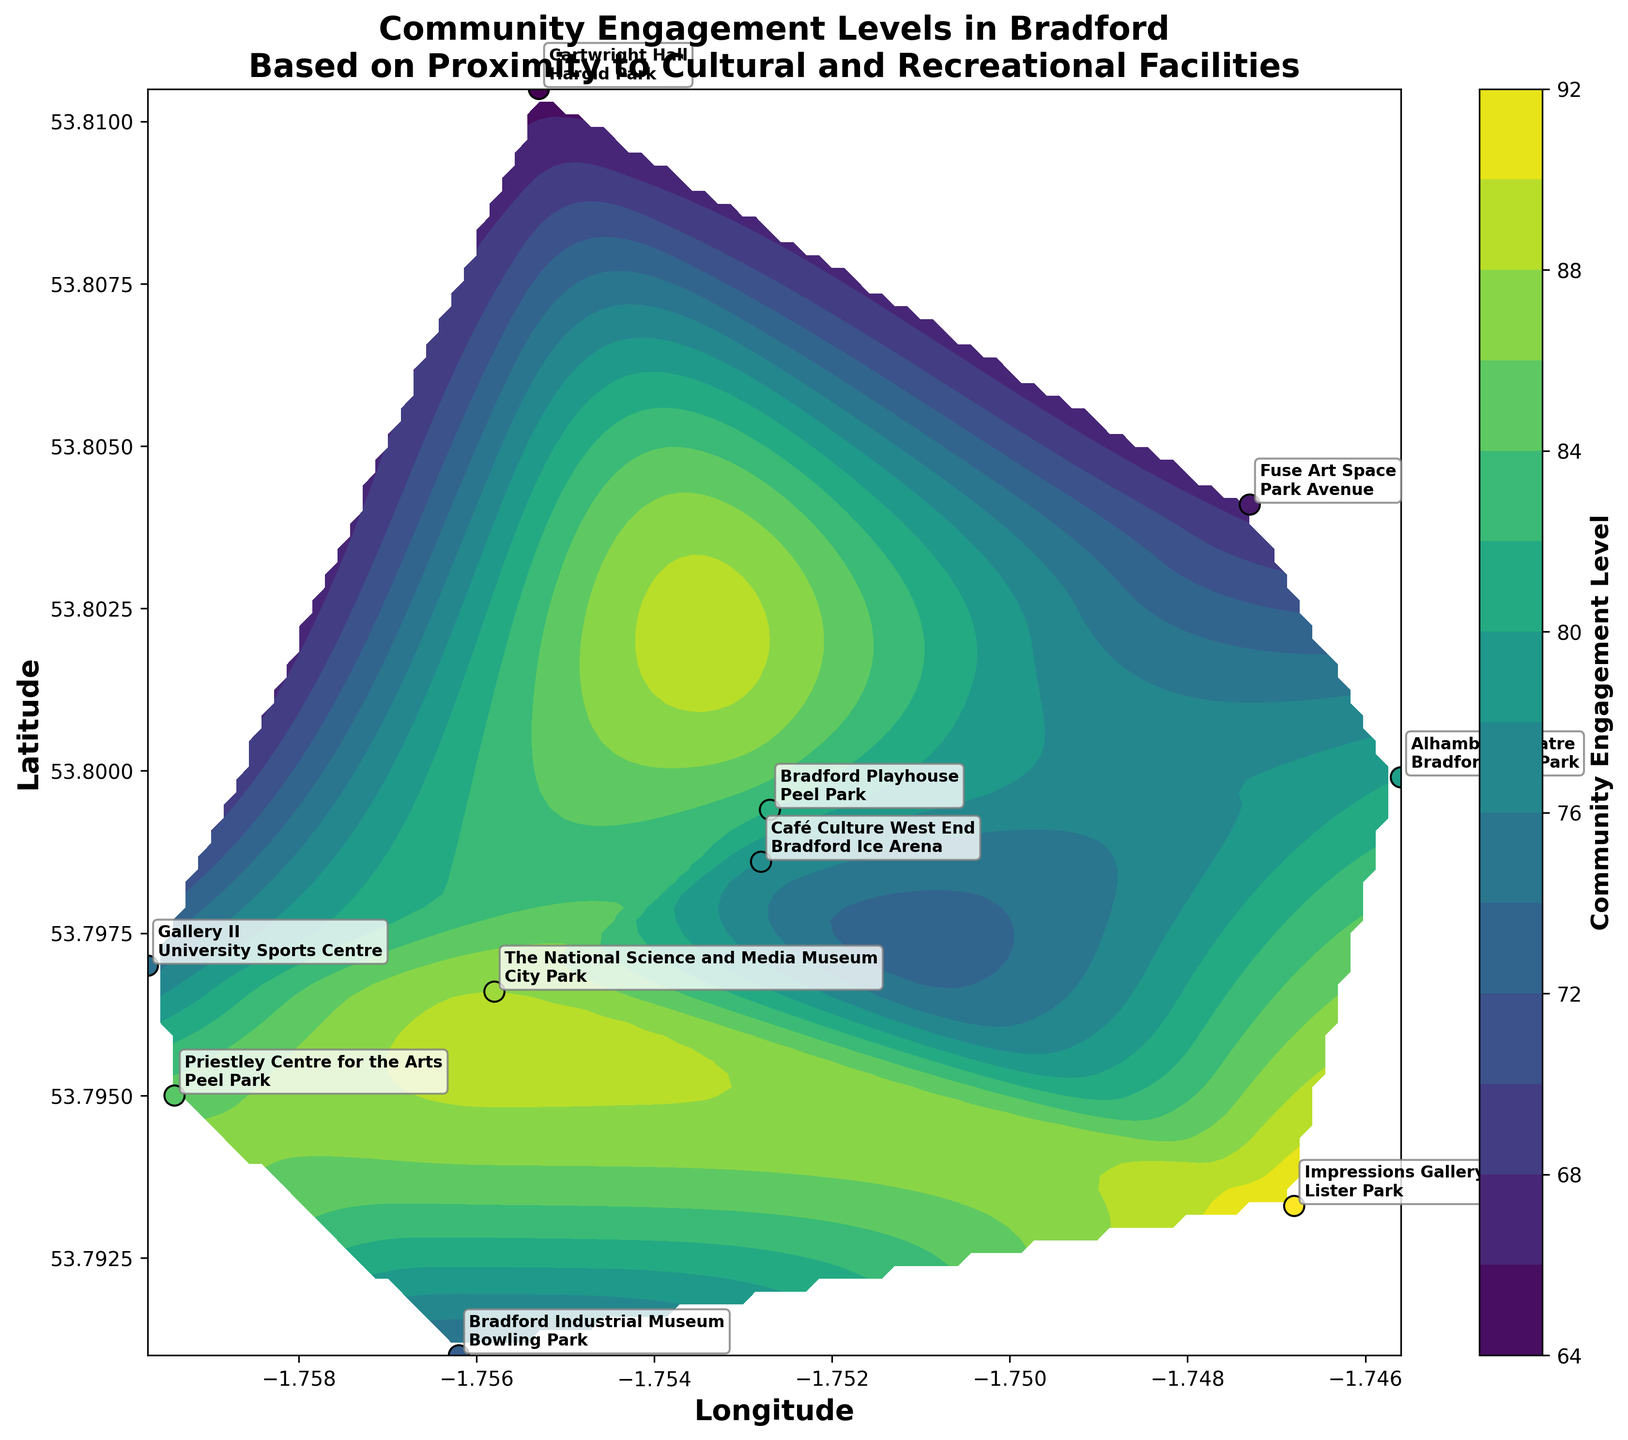How many cultural and recreational facilities are labeled on the figure? The figure contains one cultural and one recreational facility for each data point. To count the number of unique locations, we check the labels next to each scatter point.
Answer: 10 What is the title of the figure? The title of the figure is written at the top, usually in a larger and bold font.
Answer: Community Engagement Levels in Bradford Based on Proximity to Cultural and Recreational Facilities Which location has the highest community engagement level and what are the associated facilities? By looking at the scatter points and their corresponding labels, we can identify that the point with the highest community engagement level (92) is associated with "Impressions Gallery" and "Lister Park."
Answer: Impressions Gallery and Lister Park What are the latitude and longitude ranges displayed on the axes? The latitude and longitude ranges can be determined by looking at the numerical values on the x-axis and y-axis.
Answer: Latitude: 53.7910 to 53.8105, Longitude: -1.7597 to -1.7456 Compare the community engagement levels between "The National Science and Media Museum" and "Peel Park" versus "Cartwright Hall" and "Harold Park". By examining the engagement levels at the specific points, "The National Science and Media Museum" and "Peel Park" have an 88 engagement level, while "Cartwright Hall" and "Harold Park" have a 65 engagement level.
Answer: The National Science and Media Museum and Peel Park have higher engagement Which facility pair has a community engagement level of 73? By looking at the scatter points and their labels, the pair with a community engagement level of 73 is "Bradford Industrial Museum" and "Bowling Park."
Answer: Bradford Industrial Museum and Bowling Park What color represents the highest community engagement levels on the contour plot? The color bar to the right of the plot shows a gradient of colors, with the color closest to the maximum value representing the highest engagement levels. Typically, in a viridis colormap, this would be yellow.
Answer: Yellow Which facility pairs are located closest to each other in terms of geographic proximity? By observing the spatial distribution of the scatter points on the plot, we can see which points are closest to one another. "Alhambra Theatre and Bradford City Park" and "Fuse Art Space and Park Avenue" appear closest geographically.
Answer: Alhambra Theatre and Bradford City Park How does the engagement level at "Priestley Centre for the Arts and Peel Park" compare with the average community engagement levels of all the locations? First, sum all the engagement levels: 85 + 78 + 92 + 65 + 88 + 73 + 80 + 67 + 82 + 75, which equals 785. The average is 785/10 = 78.5. The engagement level at "Priestley Centre for the Arts and Peel Park" is 85, which is higher than the average.
Answer: Higher than average 